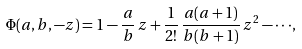Convert formula to latex. <formula><loc_0><loc_0><loc_500><loc_500>\Phi ( a , b , - z ) = 1 - \frac { a } { b } \, z + \frac { 1 } { 2 ! } \, \frac { a ( a + 1 ) } { b ( b + 1 ) } \, z ^ { 2 } - \cdot \cdot \cdot ,</formula> 